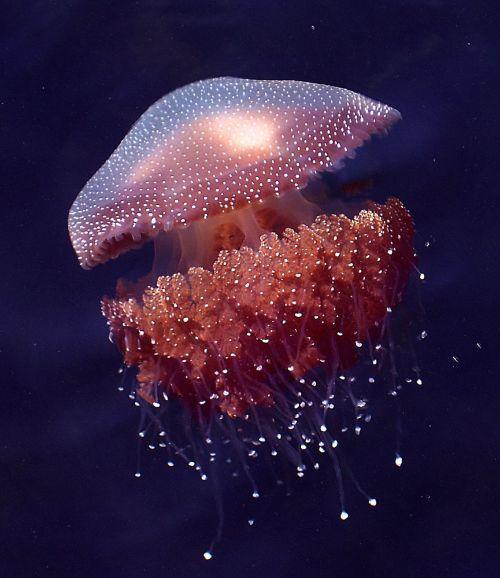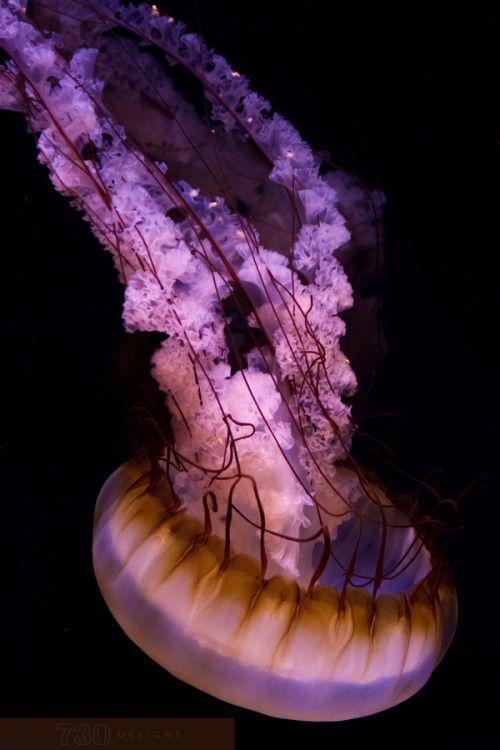The first image is the image on the left, the second image is the image on the right. Analyze the images presented: Is the assertion "The left and right image contains the same number of jellyfish." valid? Answer yes or no. Yes. The first image is the image on the left, the second image is the image on the right. Assess this claim about the two images: "The left image contains a single jellyfish, which has an upright mushroom-shaped cap that trails stringy and ruffly tentacles beneath it.". Correct or not? Answer yes or no. Yes. 